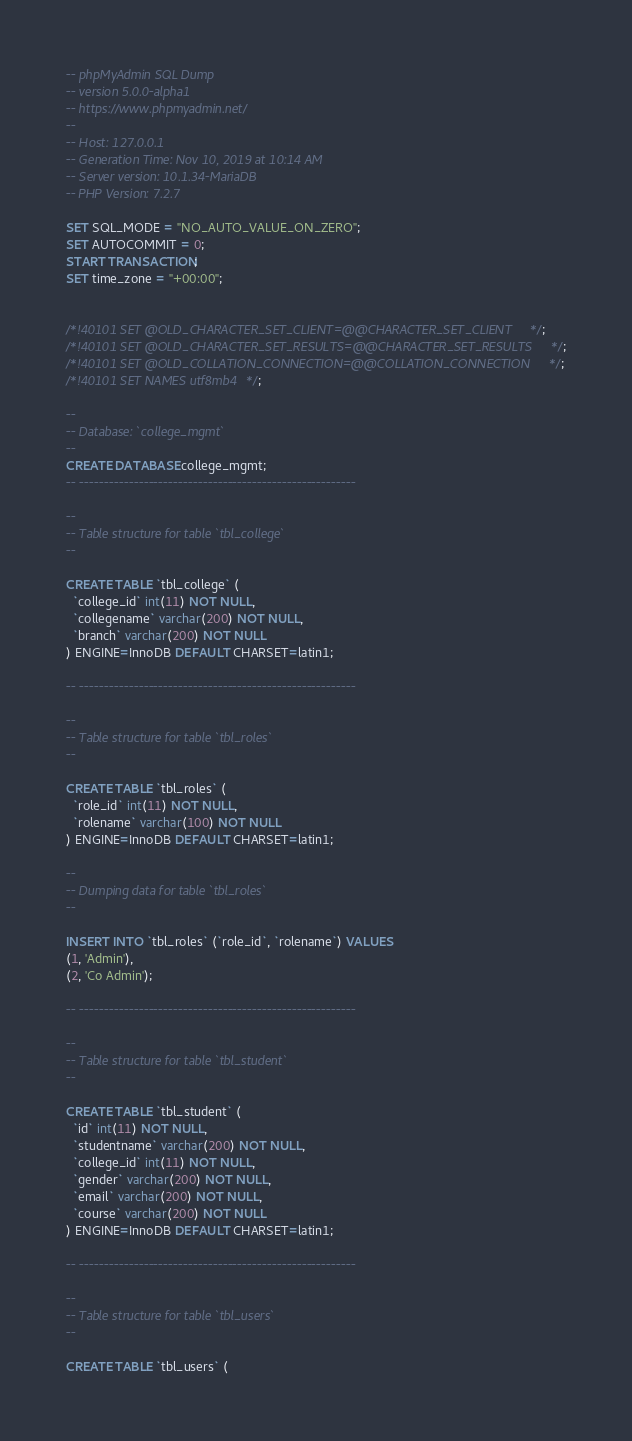Convert code to text. <code><loc_0><loc_0><loc_500><loc_500><_SQL_>-- phpMyAdmin SQL Dump
-- version 5.0.0-alpha1
-- https://www.phpmyadmin.net/
--
-- Host: 127.0.0.1
-- Generation Time: Nov 10, 2019 at 10:14 AM
-- Server version: 10.1.34-MariaDB
-- PHP Version: 7.2.7

SET SQL_MODE = "NO_AUTO_VALUE_ON_ZERO";
SET AUTOCOMMIT = 0;
START TRANSACTION;
SET time_zone = "+00:00";


/*!40101 SET @OLD_CHARACTER_SET_CLIENT=@@CHARACTER_SET_CLIENT */;
/*!40101 SET @OLD_CHARACTER_SET_RESULTS=@@CHARACTER_SET_RESULTS */;
/*!40101 SET @OLD_COLLATION_CONNECTION=@@COLLATION_CONNECTION */;
/*!40101 SET NAMES utf8mb4 */;

--
-- Database: `college_mgmt`
--
CREATE DATABASE college_mgmt;
-- --------------------------------------------------------

--
-- Table structure for table `tbl_college`
--

CREATE TABLE `tbl_college` (
  `college_id` int(11) NOT NULL,
  `collegename` varchar(200) NOT NULL,
  `branch` varchar(200) NOT NULL
) ENGINE=InnoDB DEFAULT CHARSET=latin1;

-- --------------------------------------------------------

--
-- Table structure for table `tbl_roles`
--

CREATE TABLE `tbl_roles` (
  `role_id` int(11) NOT NULL,
  `rolename` varchar(100) NOT NULL
) ENGINE=InnoDB DEFAULT CHARSET=latin1;

--
-- Dumping data for table `tbl_roles`
--

INSERT INTO `tbl_roles` (`role_id`, `rolename`) VALUES
(1, 'Admin'),
(2, 'Co Admin');

-- --------------------------------------------------------

--
-- Table structure for table `tbl_student`
--

CREATE TABLE `tbl_student` (
  `id` int(11) NOT NULL,
  `studentname` varchar(200) NOT NULL,
  `college_id` int(11) NOT NULL,
  `gender` varchar(200) NOT NULL,
  `email` varchar(200) NOT NULL,
  `course` varchar(200) NOT NULL
) ENGINE=InnoDB DEFAULT CHARSET=latin1;

-- --------------------------------------------------------

--
-- Table structure for table `tbl_users`
--

CREATE TABLE `tbl_users` (</code> 